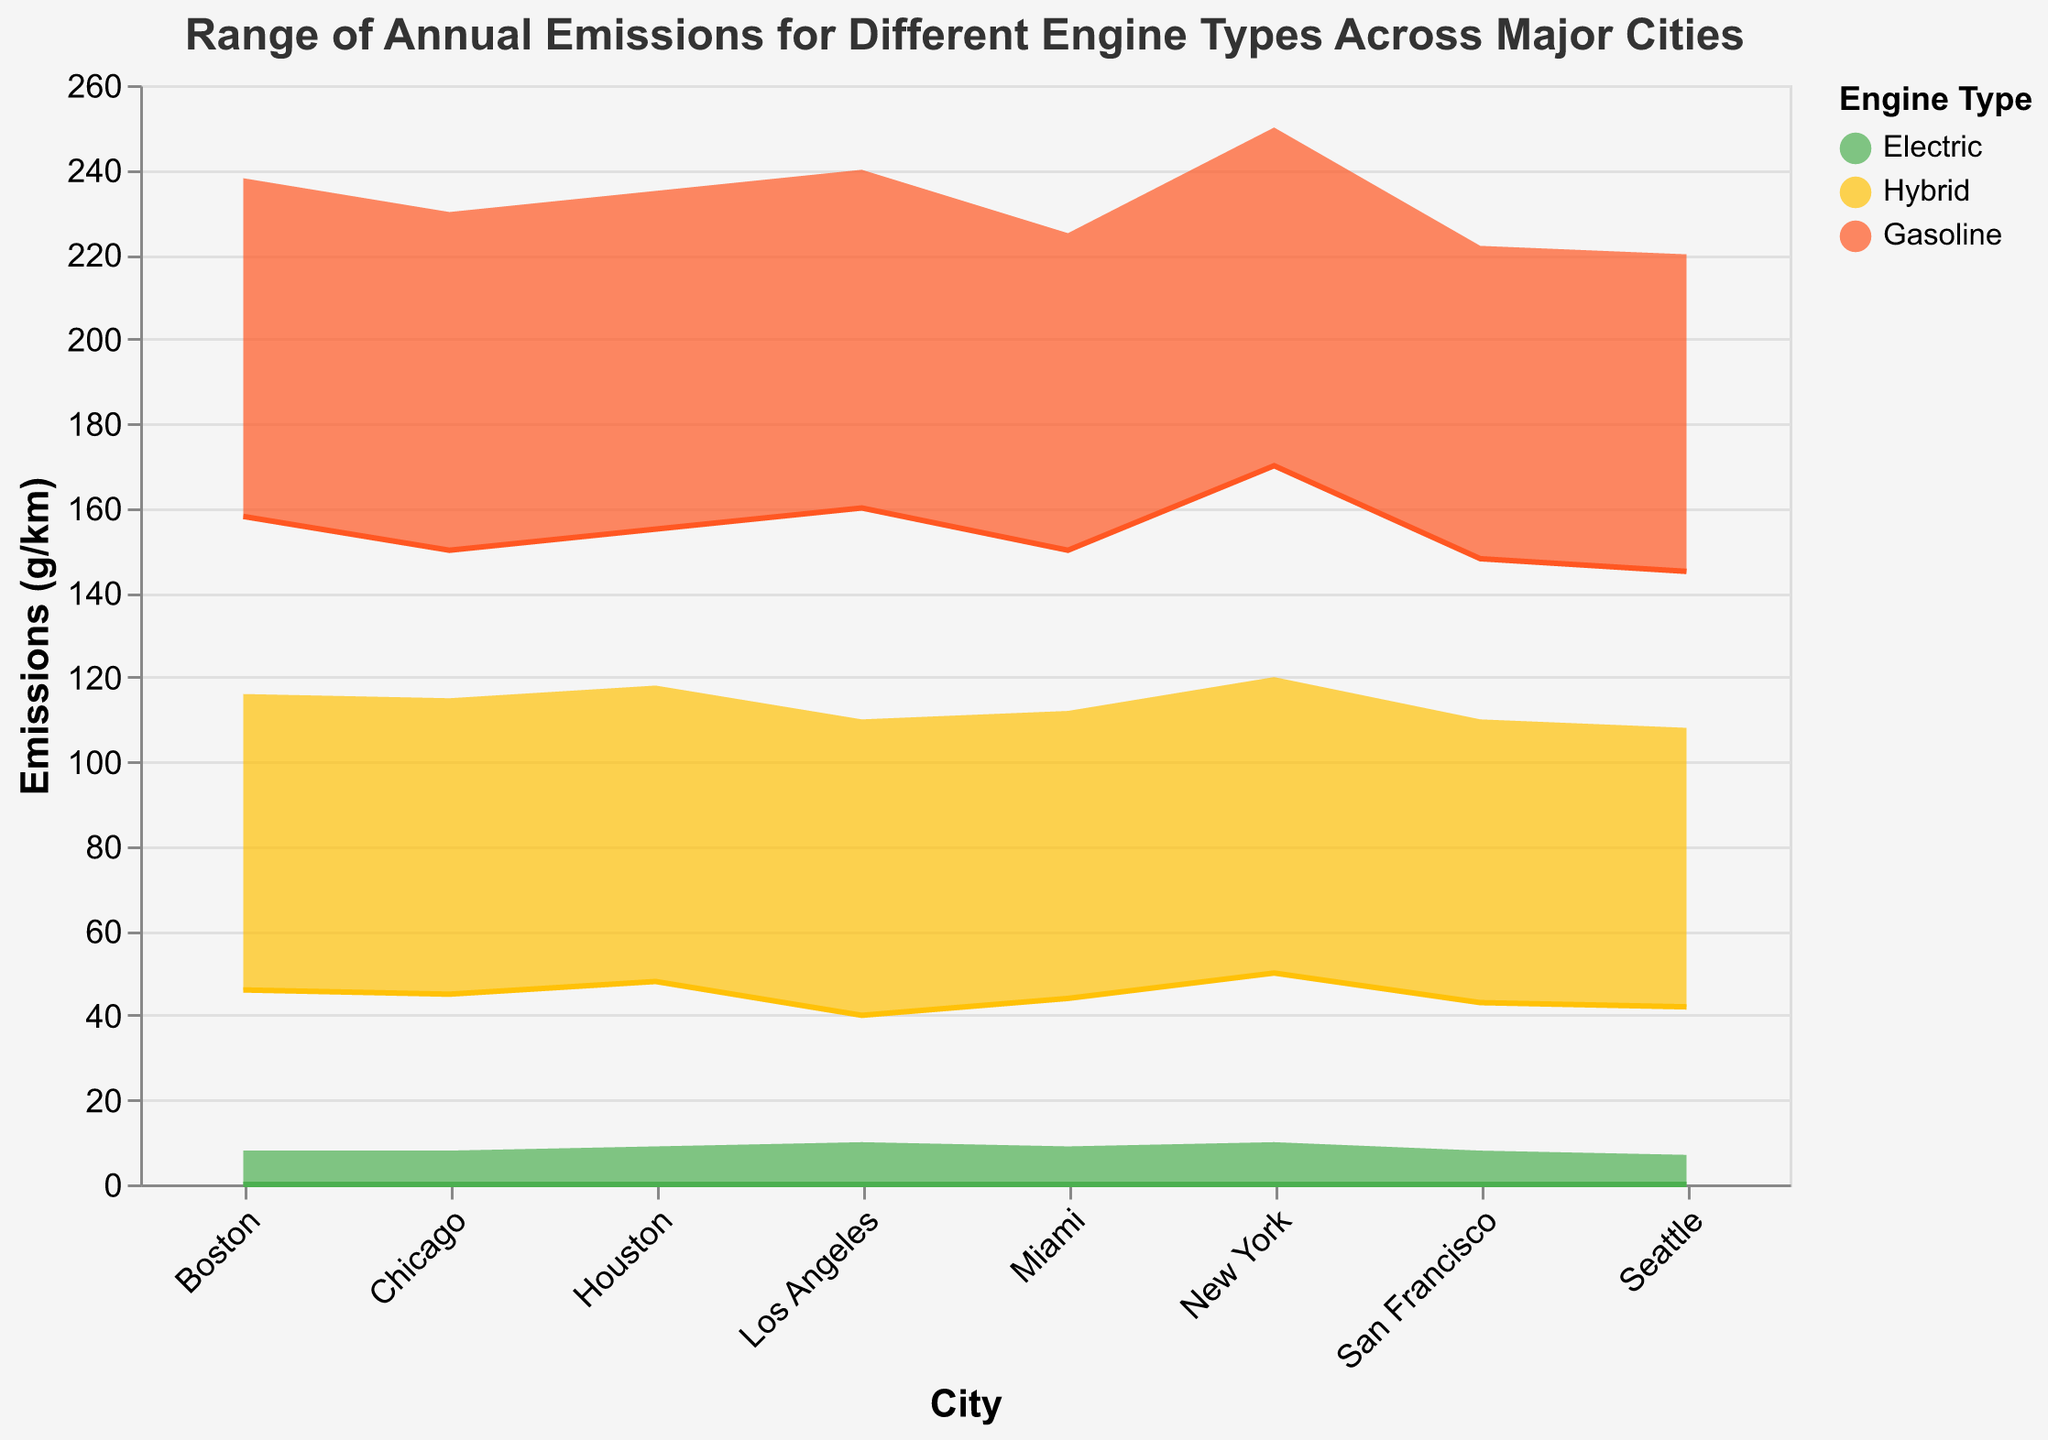What is the title of the chart? The title of the chart is located at the top and it provides a summary of what the chart is about. Here it states "Range of Annual Emissions for Different Engine Types Across Major Cities".
Answer: Range of Annual Emissions for Different Engine Types Across Major Cities Which city has the lowest maximum emissions for gasoline engines? To find the lowest maximum emissions for gasoline engines, look at the maximum emissions for gasoline engines across all cities. Seattle has the lowest maximum emissions at 220 g/km.
Answer: Seattle Among electric engines, which city has the highest minimum emissions? For each city with electric engines, check their minimum emissions. All cities with electric engines have a minimum emission of 0 g/km. Therefore, no city among those listed has a higher minimum than the others.
Answer: All cities What is the range of emissions for hybrid engines in Boston? The range of emissions is calculated by subtracting the minimum emissions value from the maximum emissions value for hybrid engines in Boston. The minimum is 46 g/km and the maximum is 116 g/km, so the range is 116 - 46 = 70 g/km.
Answer: 70 g/km Compare the range of emissions for gasoline engines in Chicago with Los Angeles. Which one is larger? The range of emissions is calculated by subtracting the minimum emissions from the maximum emissions. For Chicago, it's 230 - 150 = 80 g/km. For Los Angeles, it's 240 - 160 = 80 g/km. Both cities have the same range of emissions.
Answer: Both are the same What is the difference in maximum emissions between electric and gasoline engines in Houston? To find the difference, subtract the maximum emissions for electric engines from the maximum emissions for gasoline engines in Houston. The maximum emissions are 235 g/km for gasoline and 9 g/km for electric, so the difference is 235 - 9 = 226 g/km.
Answer: 226 g/km Which engine type consistently has the lowest emissions across all cities? By comparing the minimum and maximum emissions for each engine type across all cities, it’s clear that electric engines consistently have the lowest emissions (ranging from 0 to 10 g/km).
Answer: Electric engines 